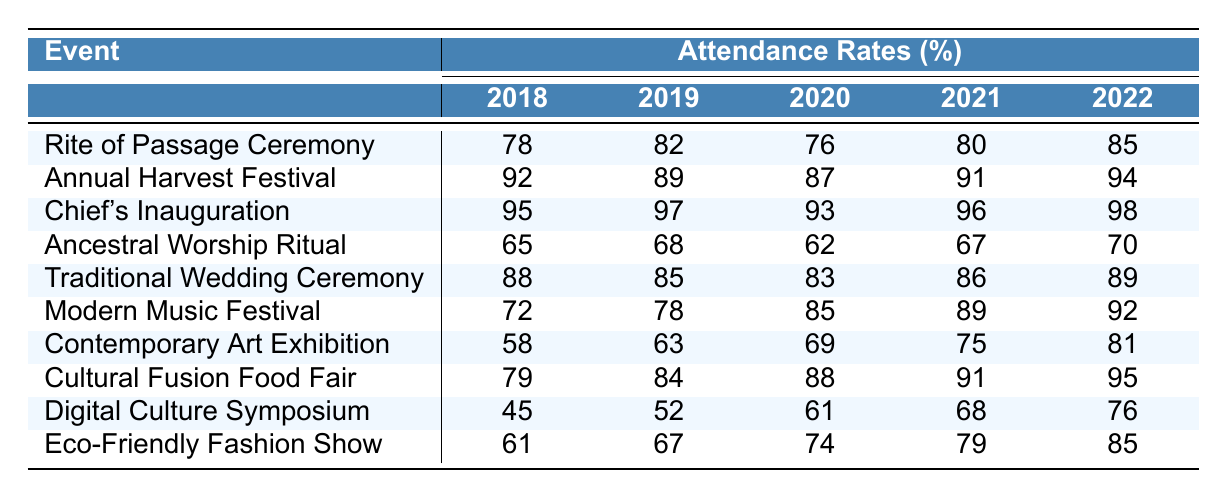What was the attendance rate for the Chief's Inauguration in 2022? The table shows the attendance rates for the Chief's Inauguration and indicates that it was 98% in 2022.
Answer: 98% Which event had the lowest attendance rate in 2020? Looking at the table, the Ancestral Worship Ritual had the lowest attendance rate with 62% in 2020.
Answer: Ancestral Worship Ritual What was the average attendance rate for the Modern Music Festival over the five years? To calculate the average, add the attendance rates: (72 + 78 + 85 + 89 + 92) = 416 and divide by 5, giving 416/5 = 83.2.
Answer: 83.2% Did the attendance rate for the Digital Culture Symposium ever exceed 70%? The attendance rates for the Digital Culture Symposium over the years are 45%, 52%, 61%, 68%, and 76%. Since 76% is the only rate above 70%, the answer is yes.
Answer: Yes What is the difference in attendance rates between the Annual Harvest Festival and the Contemporary Art Exhibition in 2021? For the Annual Harvest Festival in 2021, the rate was 91%, and for the Contemporary Art Exhibition, it was 75%. The difference is 91 - 75 = 16.
Answer: 16% Which ceremony had the highest attendance in 2019? The highest attendance in 2019 was for the Chief's Inauguration, with a rate of 97%.
Answer: Chief's Inauguration What were the attendance rates for Traditional Wedding Ceremonies from 2018 to 2022? The table lists the attendance rates as 88%, 85%, 83%, 86%, and 89% for the respective years.
Answer: 88%, 85%, 83%, 86%, 89% What is the average attendance rate for all events in 2022? To find the average, sum the attendance rates for 2022: (85 + 94 + 98 + 70 + 89 + 92 + 81 + 95 + 76 + 85) = 934, then divide by 10, yielding 934/10 = 93.4.
Answer: 93.4% How does the attendance at the Cultural Fusion Food Fair compare to the Traditional Wedding Ceremony in 2020? The attendance rate for the Cultural Fusion Food Fair in 2020 was 88%, and for the Traditional Wedding Ceremony, it was 83%. Cultural Fusion Food Fair had a higher rate by 5%.
Answer: Cultural Fusion Food Fair had 5% higher attendance What was the trend in attendance rates for the Ancestral Worship Ritual from 2018 to 2022? The attendance rates for the Ancestral Worship Ritual are 65%, 68%, 62%, 67%, and 70%. This shows a general increase starting from 2018, despite a dip in 2020.
Answer: There is an overall increasing trend 